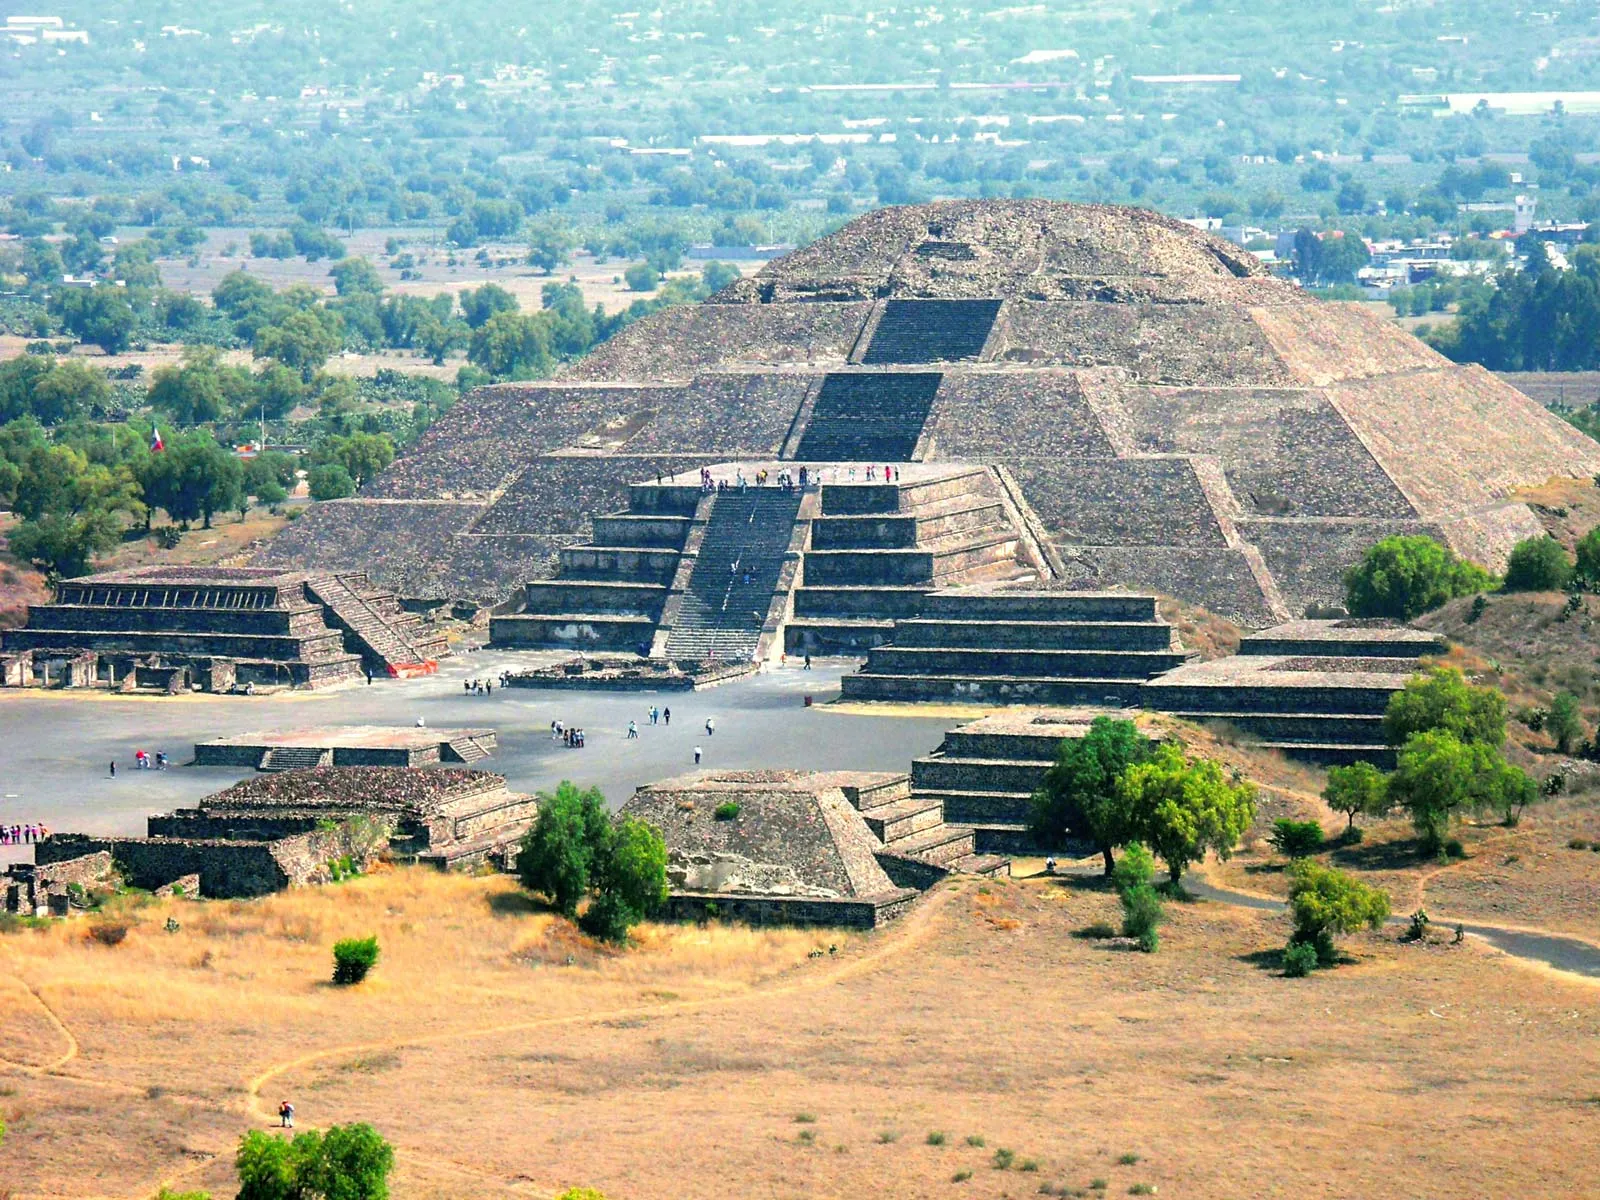Can you describe the significance of this pyramid in ancient times? The Pyramid of the Sun, standing as the largest structure in Teotihuacan and one of the largest in the Mesoamerican region, held immense significance in ancient times. It is believed to have been a focal point for religious and ceremonial activities. Constructed around 200 CE, the pyramid’s grandeur showcases the advanced engineering and architectural skills of the Teotihuacan people. It also suggests the civilization's deep knowledge of astronomy and cosmology, as its layout is thought to align with celestial events. The pyramid, therefore, not only served as a monumental marker of the city’s prosperity but also as a spiritual center that connected the people with their gods and the cosmos. 